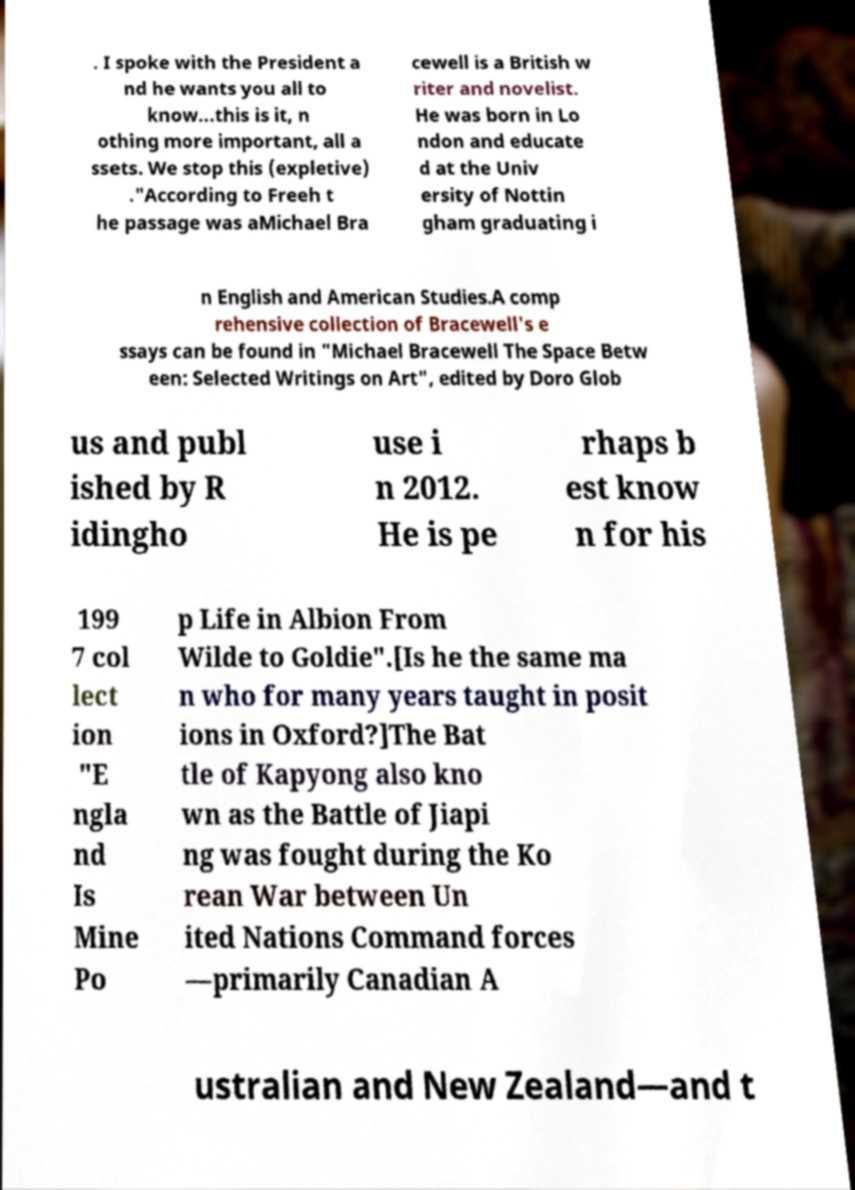For documentation purposes, I need the text within this image transcribed. Could you provide that? . I spoke with the President a nd he wants you all to know...this is it, n othing more important, all a ssets. We stop this (expletive) ."According to Freeh t he passage was aMichael Bra cewell is a British w riter and novelist. He was born in Lo ndon and educate d at the Univ ersity of Nottin gham graduating i n English and American Studies.A comp rehensive collection of Bracewell's e ssays can be found in "Michael Bracewell The Space Betw een: Selected Writings on Art", edited by Doro Glob us and publ ished by R idingho use i n 2012. He is pe rhaps b est know n for his 199 7 col lect ion "E ngla nd Is Mine Po p Life in Albion From Wilde to Goldie".[Is he the same ma n who for many years taught in posit ions in Oxford?]The Bat tle of Kapyong also kno wn as the Battle of Jiapi ng was fought during the Ko rean War between Un ited Nations Command forces —primarily Canadian A ustralian and New Zealand—and t 